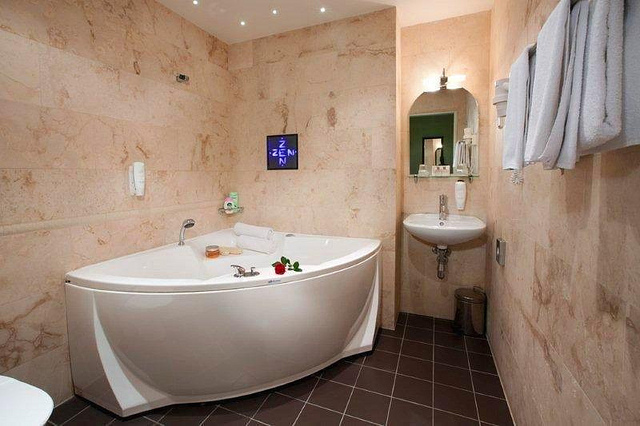Please transcribe the text information in this image. ZEN ZEN 